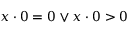Convert formula to latex. <formula><loc_0><loc_0><loc_500><loc_500>x \cdot 0 = 0 \lor x \cdot 0 > 0</formula> 